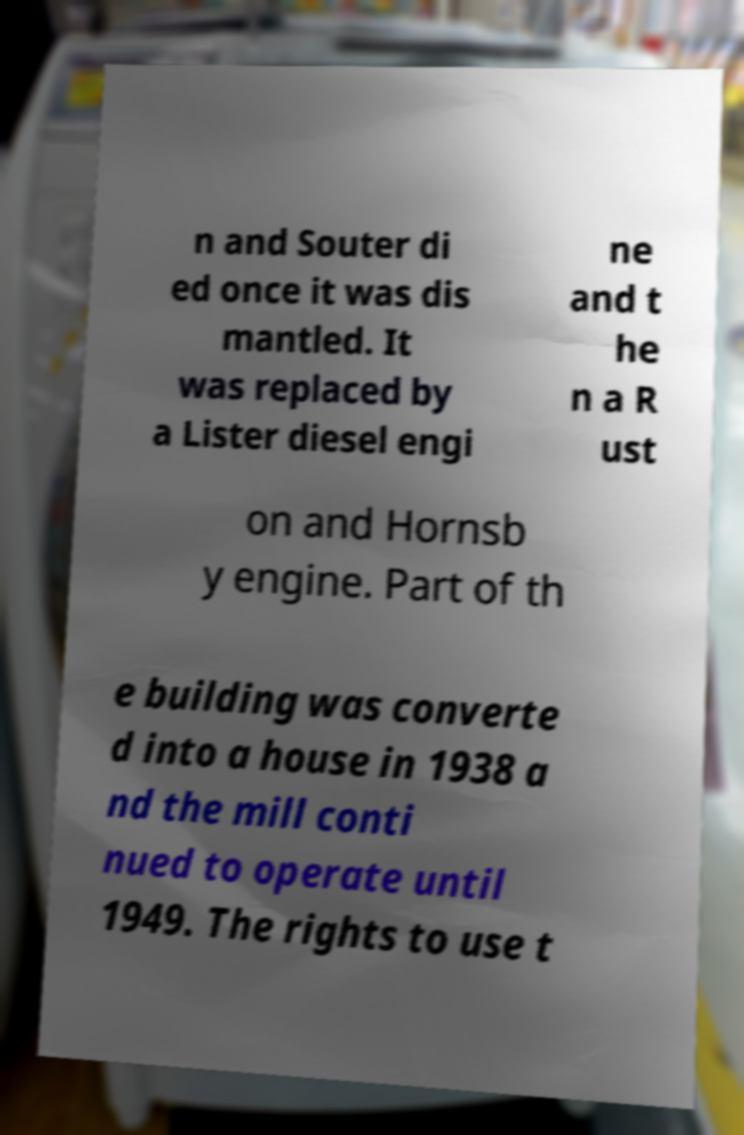For documentation purposes, I need the text within this image transcribed. Could you provide that? n and Souter di ed once it was dis mantled. It was replaced by a Lister diesel engi ne and t he n a R ust on and Hornsb y engine. Part of th e building was converte d into a house in 1938 a nd the mill conti nued to operate until 1949. The rights to use t 